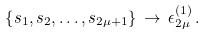Convert formula to latex. <formula><loc_0><loc_0><loc_500><loc_500>\left \{ s _ { 1 } , s _ { 2 } , \dots , s _ { 2 \mu + 1 } \right \} \, \to \, \epsilon _ { 2 \mu } ^ { ( 1 ) } \, .</formula> 